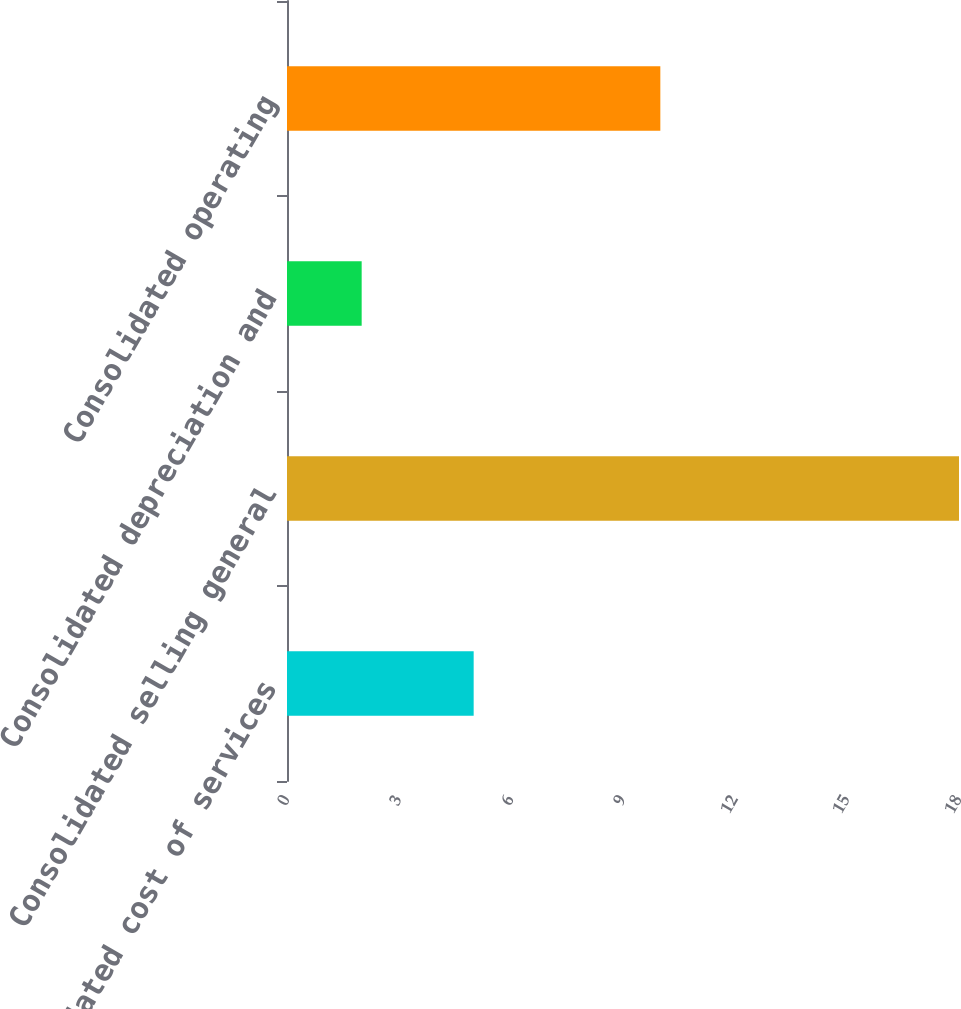Convert chart. <chart><loc_0><loc_0><loc_500><loc_500><bar_chart><fcel>Consolidated cost of services<fcel>Consolidated selling general<fcel>Consolidated depreciation and<fcel>Consolidated operating<nl><fcel>5<fcel>18<fcel>2<fcel>10<nl></chart> 